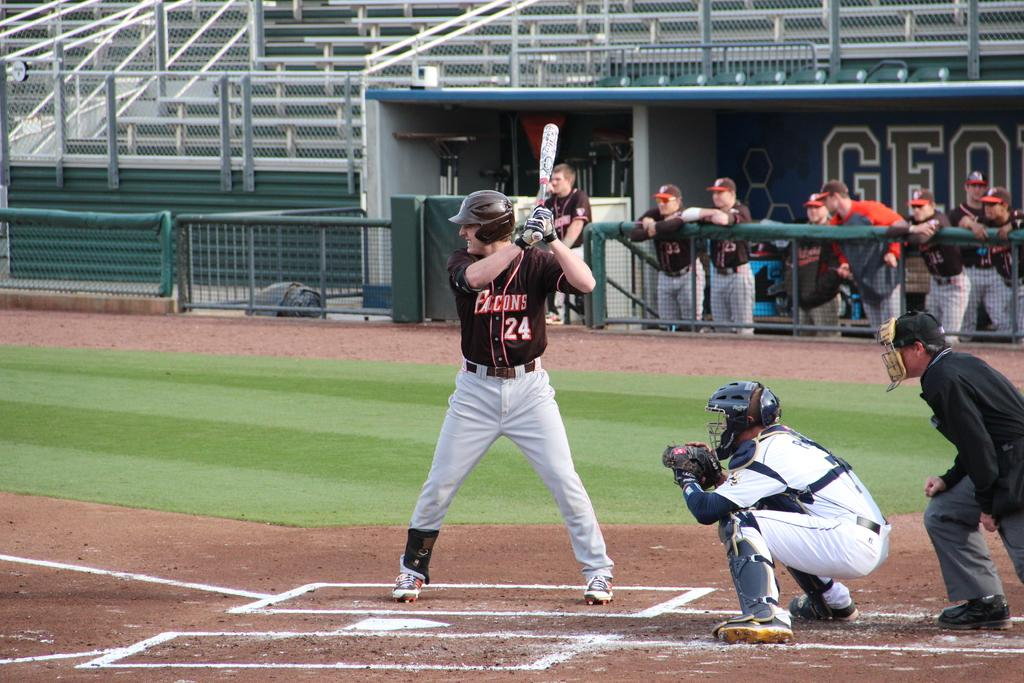<image>
Relay a brief, clear account of the picture shown. The Falcons player number 24 is at bat. 